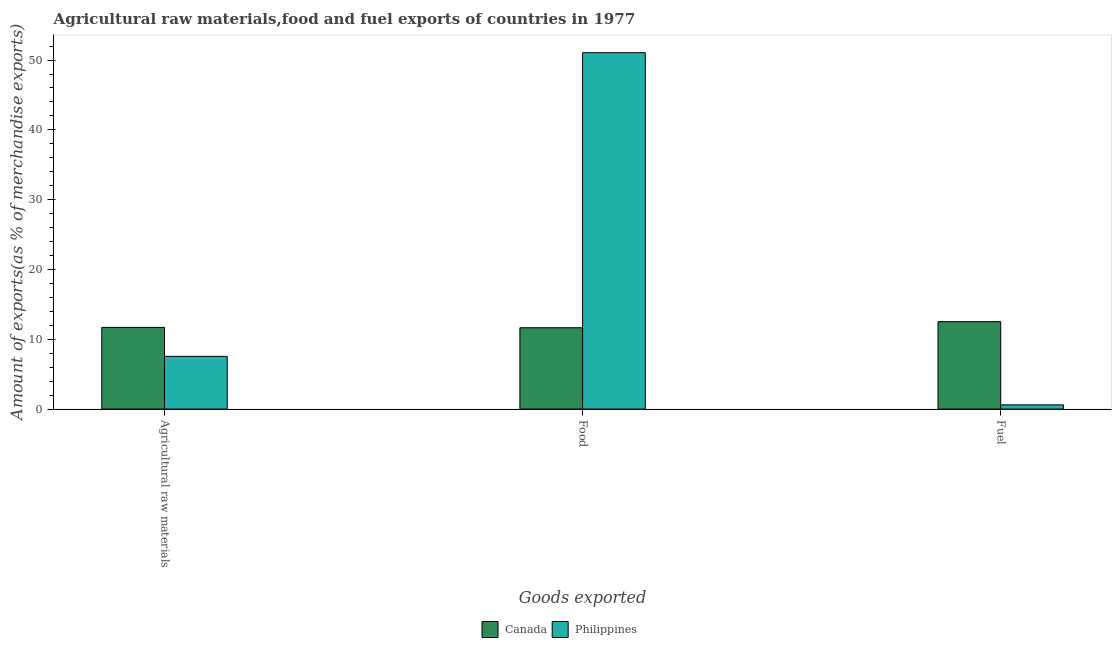How many different coloured bars are there?
Your response must be concise. 2. How many groups of bars are there?
Ensure brevity in your answer.  3. Are the number of bars per tick equal to the number of legend labels?
Keep it short and to the point. Yes. Are the number of bars on each tick of the X-axis equal?
Provide a succinct answer. Yes. What is the label of the 3rd group of bars from the left?
Keep it short and to the point. Fuel. What is the percentage of food exports in Canada?
Your answer should be very brief. 11.65. Across all countries, what is the maximum percentage of fuel exports?
Offer a very short reply. 12.52. Across all countries, what is the minimum percentage of fuel exports?
Give a very brief answer. 0.61. In which country was the percentage of food exports maximum?
Provide a succinct answer. Philippines. What is the total percentage of raw materials exports in the graph?
Provide a short and direct response. 19.25. What is the difference between the percentage of raw materials exports in Canada and that in Philippines?
Your response must be concise. 4.15. What is the difference between the percentage of fuel exports in Canada and the percentage of raw materials exports in Philippines?
Your answer should be compact. 4.97. What is the average percentage of food exports per country?
Provide a short and direct response. 31.35. What is the difference between the percentage of raw materials exports and percentage of food exports in Philippines?
Provide a succinct answer. -43.5. What is the ratio of the percentage of raw materials exports in Canada to that in Philippines?
Your answer should be very brief. 1.55. Is the percentage of raw materials exports in Canada less than that in Philippines?
Offer a terse response. No. What is the difference between the highest and the second highest percentage of food exports?
Offer a very short reply. 39.4. What is the difference between the highest and the lowest percentage of food exports?
Provide a succinct answer. 39.4. In how many countries, is the percentage of fuel exports greater than the average percentage of fuel exports taken over all countries?
Offer a very short reply. 1. Is the sum of the percentage of food exports in Philippines and Canada greater than the maximum percentage of raw materials exports across all countries?
Keep it short and to the point. Yes. What does the 1st bar from the right in Agricultural raw materials represents?
Offer a terse response. Philippines. Is it the case that in every country, the sum of the percentage of raw materials exports and percentage of food exports is greater than the percentage of fuel exports?
Keep it short and to the point. Yes. Are all the bars in the graph horizontal?
Offer a very short reply. No. What is the difference between two consecutive major ticks on the Y-axis?
Make the answer very short. 10. Where does the legend appear in the graph?
Give a very brief answer. Bottom center. How many legend labels are there?
Your answer should be very brief. 2. How are the legend labels stacked?
Give a very brief answer. Horizontal. What is the title of the graph?
Offer a terse response. Agricultural raw materials,food and fuel exports of countries in 1977. Does "Korea (Republic)" appear as one of the legend labels in the graph?
Ensure brevity in your answer.  No. What is the label or title of the X-axis?
Provide a succinct answer. Goods exported. What is the label or title of the Y-axis?
Offer a terse response. Amount of exports(as % of merchandise exports). What is the Amount of exports(as % of merchandise exports) in Canada in Agricultural raw materials?
Provide a succinct answer. 11.7. What is the Amount of exports(as % of merchandise exports) of Philippines in Agricultural raw materials?
Your answer should be compact. 7.55. What is the Amount of exports(as % of merchandise exports) in Canada in Food?
Give a very brief answer. 11.65. What is the Amount of exports(as % of merchandise exports) of Philippines in Food?
Offer a very short reply. 51.05. What is the Amount of exports(as % of merchandise exports) of Canada in Fuel?
Provide a short and direct response. 12.52. What is the Amount of exports(as % of merchandise exports) of Philippines in Fuel?
Provide a succinct answer. 0.61. Across all Goods exported, what is the maximum Amount of exports(as % of merchandise exports) in Canada?
Ensure brevity in your answer.  12.52. Across all Goods exported, what is the maximum Amount of exports(as % of merchandise exports) in Philippines?
Keep it short and to the point. 51.05. Across all Goods exported, what is the minimum Amount of exports(as % of merchandise exports) in Canada?
Make the answer very short. 11.65. Across all Goods exported, what is the minimum Amount of exports(as % of merchandise exports) of Philippines?
Provide a succinct answer. 0.61. What is the total Amount of exports(as % of merchandise exports) of Canada in the graph?
Provide a succinct answer. 35.87. What is the total Amount of exports(as % of merchandise exports) in Philippines in the graph?
Offer a terse response. 59.21. What is the difference between the Amount of exports(as % of merchandise exports) in Canada in Agricultural raw materials and that in Food?
Offer a very short reply. 0.05. What is the difference between the Amount of exports(as % of merchandise exports) in Philippines in Agricultural raw materials and that in Food?
Your answer should be very brief. -43.5. What is the difference between the Amount of exports(as % of merchandise exports) in Canada in Agricultural raw materials and that in Fuel?
Your answer should be very brief. -0.82. What is the difference between the Amount of exports(as % of merchandise exports) in Philippines in Agricultural raw materials and that in Fuel?
Give a very brief answer. 6.95. What is the difference between the Amount of exports(as % of merchandise exports) of Canada in Food and that in Fuel?
Offer a terse response. -0.87. What is the difference between the Amount of exports(as % of merchandise exports) in Philippines in Food and that in Fuel?
Give a very brief answer. 50.45. What is the difference between the Amount of exports(as % of merchandise exports) of Canada in Agricultural raw materials and the Amount of exports(as % of merchandise exports) of Philippines in Food?
Keep it short and to the point. -39.35. What is the difference between the Amount of exports(as % of merchandise exports) of Canada in Agricultural raw materials and the Amount of exports(as % of merchandise exports) of Philippines in Fuel?
Offer a very short reply. 11.09. What is the difference between the Amount of exports(as % of merchandise exports) of Canada in Food and the Amount of exports(as % of merchandise exports) of Philippines in Fuel?
Ensure brevity in your answer.  11.05. What is the average Amount of exports(as % of merchandise exports) of Canada per Goods exported?
Your response must be concise. 11.96. What is the average Amount of exports(as % of merchandise exports) in Philippines per Goods exported?
Give a very brief answer. 19.74. What is the difference between the Amount of exports(as % of merchandise exports) of Canada and Amount of exports(as % of merchandise exports) of Philippines in Agricultural raw materials?
Offer a very short reply. 4.15. What is the difference between the Amount of exports(as % of merchandise exports) of Canada and Amount of exports(as % of merchandise exports) of Philippines in Food?
Keep it short and to the point. -39.4. What is the difference between the Amount of exports(as % of merchandise exports) of Canada and Amount of exports(as % of merchandise exports) of Philippines in Fuel?
Ensure brevity in your answer.  11.92. What is the ratio of the Amount of exports(as % of merchandise exports) of Canada in Agricultural raw materials to that in Food?
Provide a succinct answer. 1. What is the ratio of the Amount of exports(as % of merchandise exports) of Philippines in Agricultural raw materials to that in Food?
Make the answer very short. 0.15. What is the ratio of the Amount of exports(as % of merchandise exports) of Canada in Agricultural raw materials to that in Fuel?
Keep it short and to the point. 0.93. What is the ratio of the Amount of exports(as % of merchandise exports) of Philippines in Agricultural raw materials to that in Fuel?
Keep it short and to the point. 12.48. What is the ratio of the Amount of exports(as % of merchandise exports) of Canada in Food to that in Fuel?
Offer a very short reply. 0.93. What is the ratio of the Amount of exports(as % of merchandise exports) of Philippines in Food to that in Fuel?
Offer a terse response. 84.35. What is the difference between the highest and the second highest Amount of exports(as % of merchandise exports) of Canada?
Keep it short and to the point. 0.82. What is the difference between the highest and the second highest Amount of exports(as % of merchandise exports) of Philippines?
Provide a succinct answer. 43.5. What is the difference between the highest and the lowest Amount of exports(as % of merchandise exports) of Canada?
Your answer should be compact. 0.87. What is the difference between the highest and the lowest Amount of exports(as % of merchandise exports) of Philippines?
Ensure brevity in your answer.  50.45. 